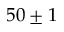<formula> <loc_0><loc_0><loc_500><loc_500>5 0 \pm 1</formula> 